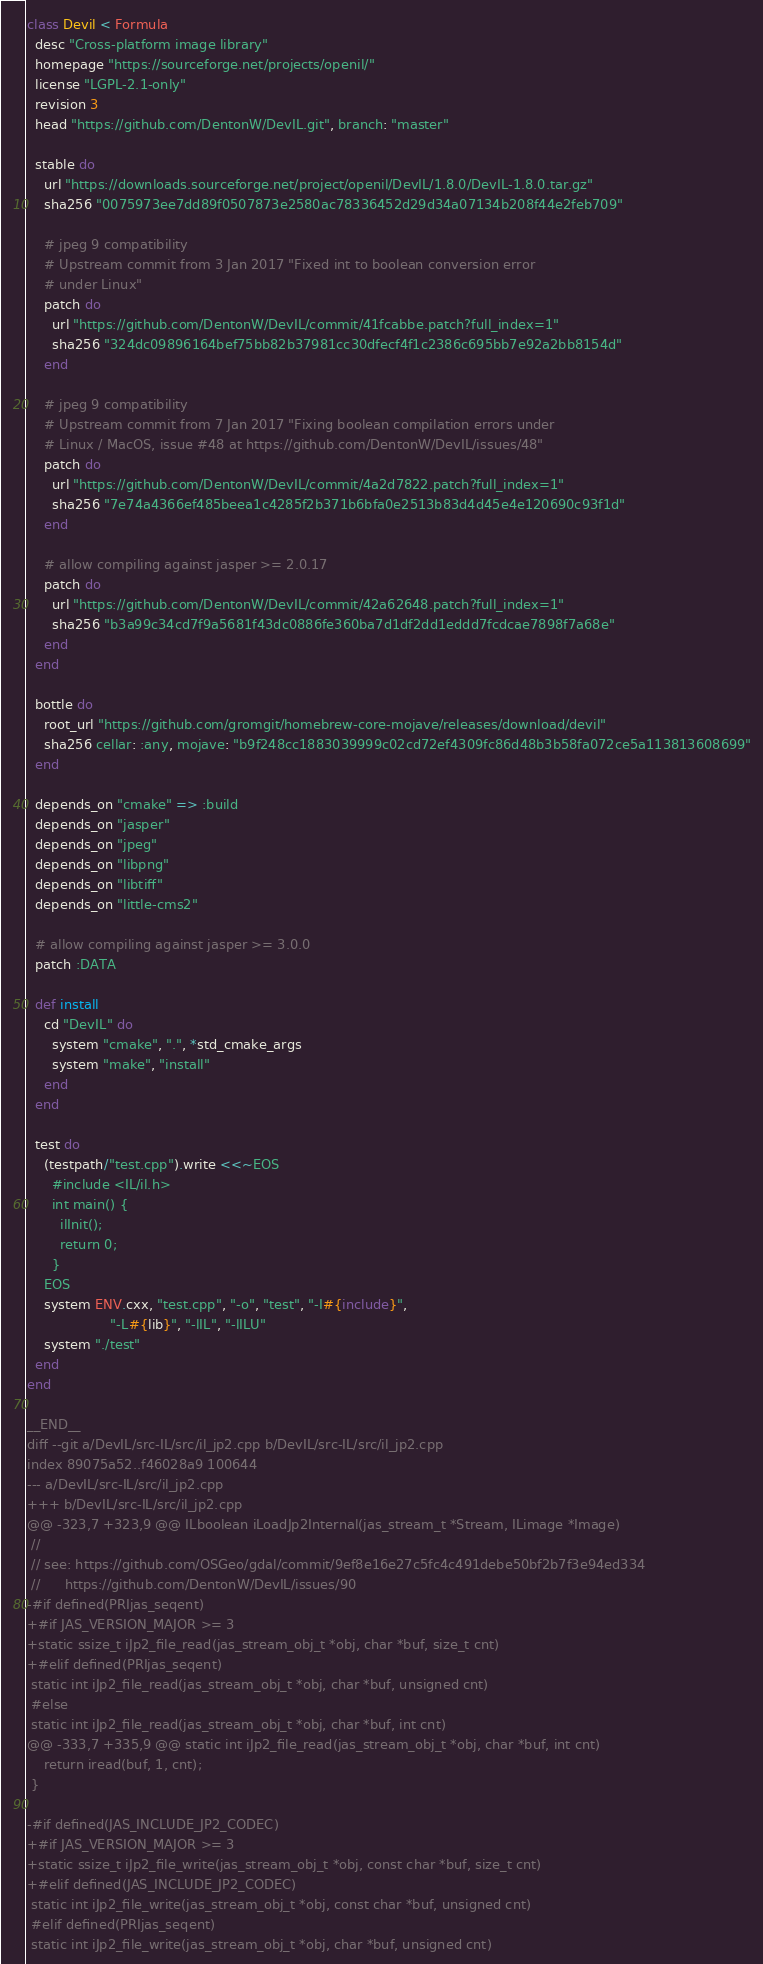Convert code to text. <code><loc_0><loc_0><loc_500><loc_500><_Ruby_>class Devil < Formula
  desc "Cross-platform image library"
  homepage "https://sourceforge.net/projects/openil/"
  license "LGPL-2.1-only"
  revision 3
  head "https://github.com/DentonW/DevIL.git", branch: "master"

  stable do
    url "https://downloads.sourceforge.net/project/openil/DevIL/1.8.0/DevIL-1.8.0.tar.gz"
    sha256 "0075973ee7dd89f0507873e2580ac78336452d29d34a07134b208f44e2feb709"

    # jpeg 9 compatibility
    # Upstream commit from 3 Jan 2017 "Fixed int to boolean conversion error
    # under Linux"
    patch do
      url "https://github.com/DentonW/DevIL/commit/41fcabbe.patch?full_index=1"
      sha256 "324dc09896164bef75bb82b37981cc30dfecf4f1c2386c695bb7e92a2bb8154d"
    end

    # jpeg 9 compatibility
    # Upstream commit from 7 Jan 2017 "Fixing boolean compilation errors under
    # Linux / MacOS, issue #48 at https://github.com/DentonW/DevIL/issues/48"
    patch do
      url "https://github.com/DentonW/DevIL/commit/4a2d7822.patch?full_index=1"
      sha256 "7e74a4366ef485beea1c4285f2b371b6bfa0e2513b83d4d45e4e120690c93f1d"
    end

    # allow compiling against jasper >= 2.0.17
    patch do
      url "https://github.com/DentonW/DevIL/commit/42a62648.patch?full_index=1"
      sha256 "b3a99c34cd7f9a5681f43dc0886fe360ba7d1df2dd1eddd7fcdcae7898f7a68e"
    end
  end

  bottle do
    root_url "https://github.com/gromgit/homebrew-core-mojave/releases/download/devil"
    sha256 cellar: :any, mojave: "b9f248cc1883039999c02cd72ef4309fc86d48b3b58fa072ce5a113813608699"
  end

  depends_on "cmake" => :build
  depends_on "jasper"
  depends_on "jpeg"
  depends_on "libpng"
  depends_on "libtiff"
  depends_on "little-cms2"

  # allow compiling against jasper >= 3.0.0
  patch :DATA

  def install
    cd "DevIL" do
      system "cmake", ".", *std_cmake_args
      system "make", "install"
    end
  end

  test do
    (testpath/"test.cpp").write <<~EOS
      #include <IL/il.h>
      int main() {
        ilInit();
        return 0;
      }
    EOS
    system ENV.cxx, "test.cpp", "-o", "test", "-I#{include}",
                    "-L#{lib}", "-lIL", "-lILU"
    system "./test"
  end
end

__END__
diff --git a/DevIL/src-IL/src/il_jp2.cpp b/DevIL/src-IL/src/il_jp2.cpp
index 89075a52..f46028a9 100644
--- a/DevIL/src-IL/src/il_jp2.cpp
+++ b/DevIL/src-IL/src/il_jp2.cpp
@@ -323,7 +323,9 @@ ILboolean iLoadJp2Internal(jas_stream_t	*Stream, ILimage *Image)
 //
 // see: https://github.com/OSGeo/gdal/commit/9ef8e16e27c5fc4c491debe50bf2b7f3e94ed334
 //      https://github.com/DentonW/DevIL/issues/90
-#if defined(PRIjas_seqent)
+#if JAS_VERSION_MAJOR >= 3
+static ssize_t iJp2_file_read(jas_stream_obj_t *obj, char *buf, size_t cnt)
+#elif defined(PRIjas_seqent)
 static int iJp2_file_read(jas_stream_obj_t *obj, char *buf, unsigned cnt)
 #else
 static int iJp2_file_read(jas_stream_obj_t *obj, char *buf, int cnt)
@@ -333,7 +335,9 @@ static int iJp2_file_read(jas_stream_obj_t *obj, char *buf, int cnt)
 	return iread(buf, 1, cnt);
 }

-#if defined(JAS_INCLUDE_JP2_CODEC)
+#if JAS_VERSION_MAJOR >= 3
+static ssize_t iJp2_file_write(jas_stream_obj_t *obj, const char *buf, size_t cnt)
+#elif defined(JAS_INCLUDE_JP2_CODEC)
 static int iJp2_file_write(jas_stream_obj_t *obj, const char *buf, unsigned cnt)
 #elif defined(PRIjas_seqent)
 static int iJp2_file_write(jas_stream_obj_t *obj, char *buf, unsigned cnt)
</code> 